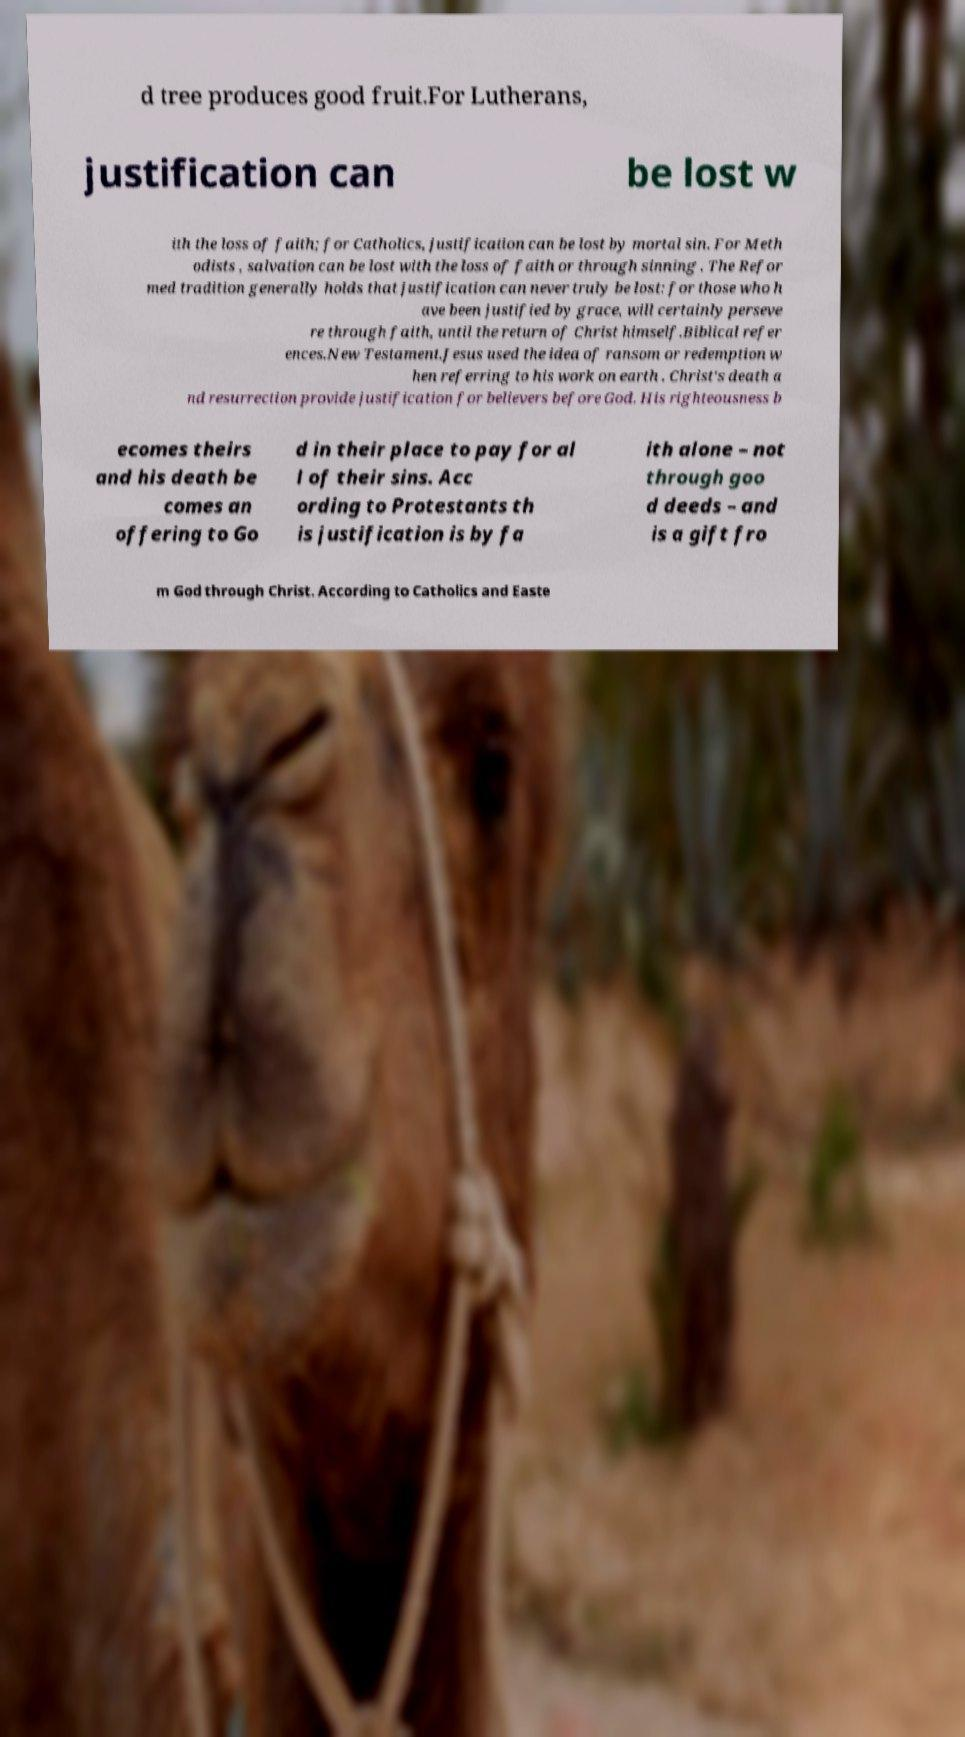Can you accurately transcribe the text from the provided image for me? d tree produces good fruit.For Lutherans, justification can be lost w ith the loss of faith; for Catholics, justification can be lost by mortal sin. For Meth odists , salvation can be lost with the loss of faith or through sinning . The Refor med tradition generally holds that justification can never truly be lost: for those who h ave been justified by grace, will certainly perseve re through faith, until the return of Christ himself.Biblical refer ences.New Testament.Jesus used the idea of ransom or redemption w hen referring to his work on earth . Christ's death a nd resurrection provide justification for believers before God. His righteousness b ecomes theirs and his death be comes an offering to Go d in their place to pay for al l of their sins. Acc ording to Protestants th is justification is by fa ith alone – not through goo d deeds – and is a gift fro m God through Christ. According to Catholics and Easte 